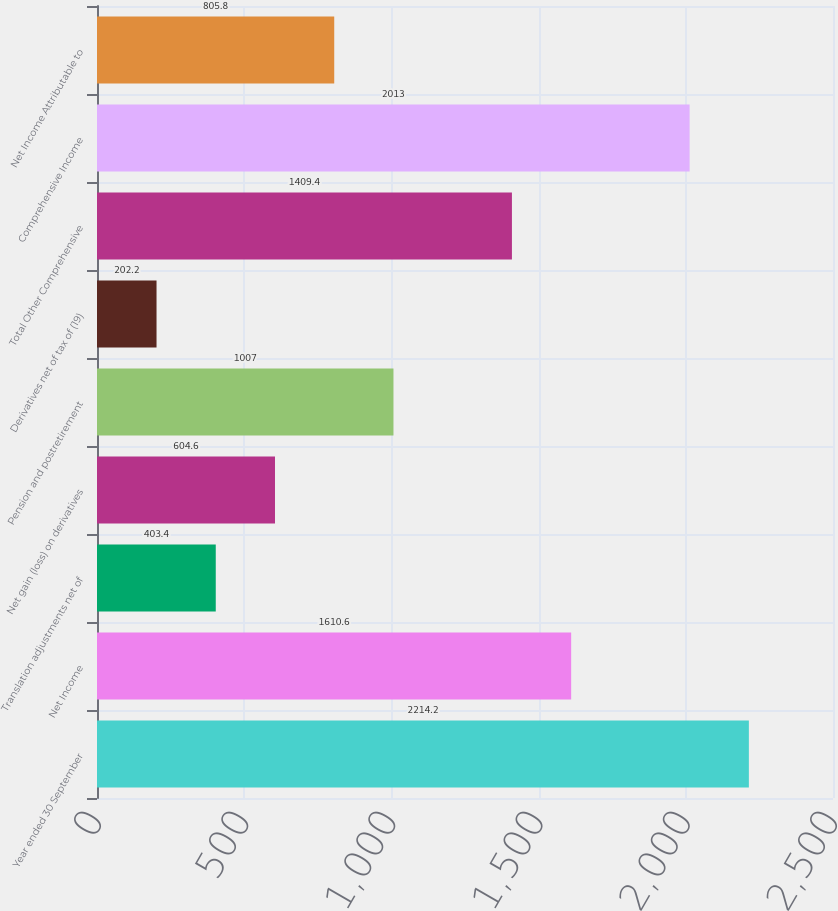Convert chart to OTSL. <chart><loc_0><loc_0><loc_500><loc_500><bar_chart><fcel>Year ended 30 September<fcel>Net Income<fcel>Translation adjustments net of<fcel>Net gain (loss) on derivatives<fcel>Pension and postretirement<fcel>Derivatives net of tax of (19)<fcel>Total Other Comprehensive<fcel>Comprehensive Income<fcel>Net Income Attributable to<nl><fcel>2214.2<fcel>1610.6<fcel>403.4<fcel>604.6<fcel>1007<fcel>202.2<fcel>1409.4<fcel>2013<fcel>805.8<nl></chart> 